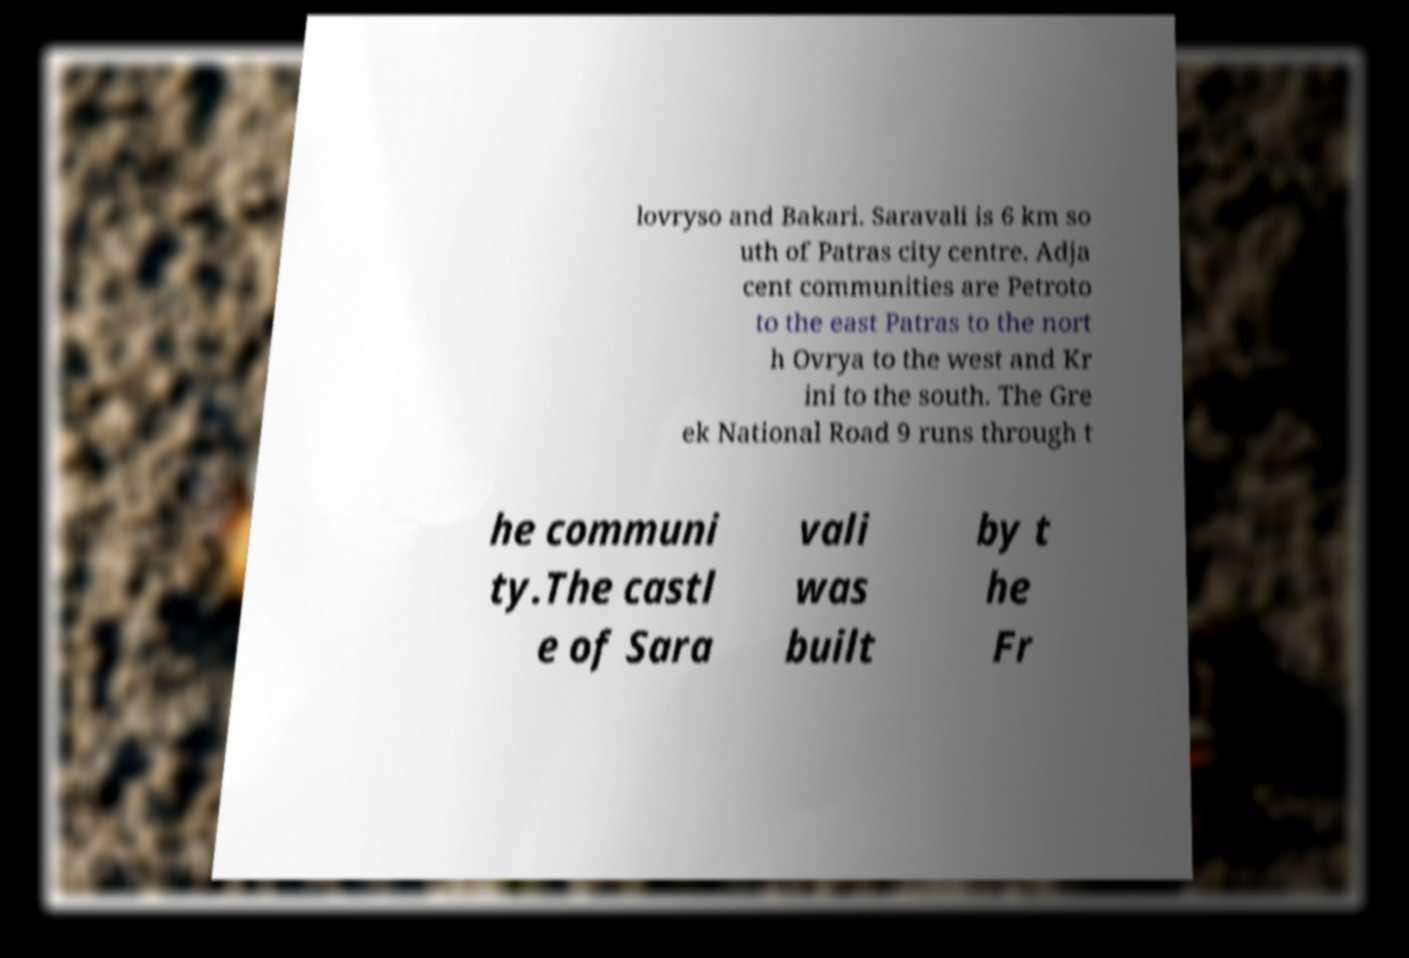For documentation purposes, I need the text within this image transcribed. Could you provide that? lovryso and Bakari. Saravali is 6 km so uth of Patras city centre. Adja cent communities are Petroto to the east Patras to the nort h Ovrya to the west and Kr ini to the south. The Gre ek National Road 9 runs through t he communi ty.The castl e of Sara vali was built by t he Fr 